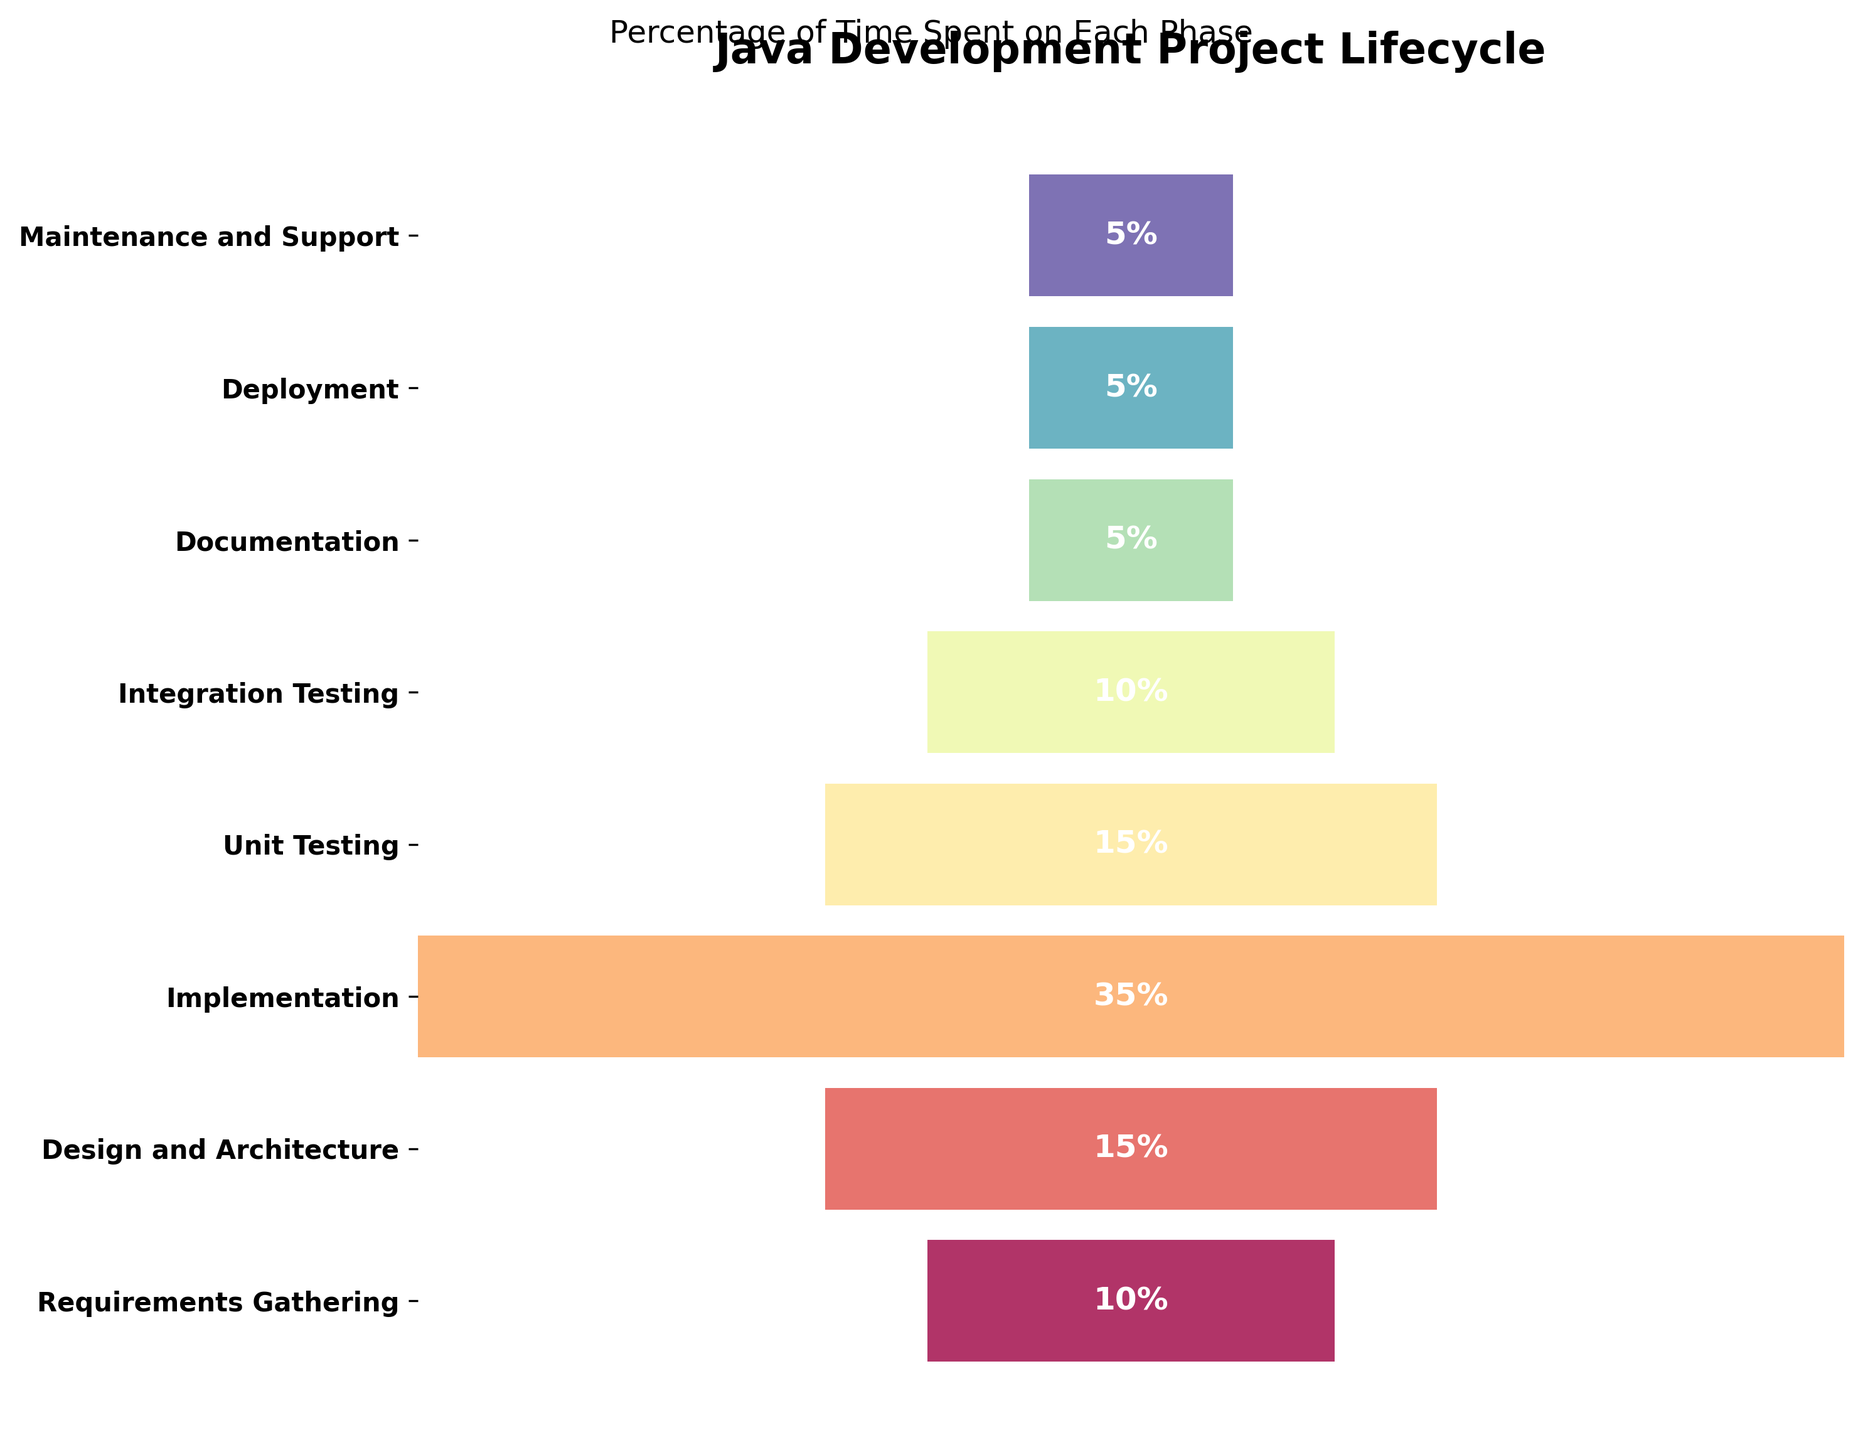What's the highest percentage of time spent on a single phase? The highest percentage can be determined by looking at the values given for each stage. The stage with the highest bar represents the highest percentage. From the figure, the 'Implementation' stage has the highest value.
Answer: 35% Which stages have an equal percentage of time spent? By comparing the percentages listed for each stage, we can see that 'Unit Testing', 'Integration Testing', 'Documentation', 'Deployment', and 'Maintenance and Support' phases all have the same value of 5%.
Answer: Documentation, Deployment, Maintenance and Support How much time in total is spent on testing phases? The testing phases here include 'Unit Testing' and 'Integration Testing'. Adding their percentages gives us 15% + 10%.
Answer: 25% Which phase has the smallest percentage of time allocated to it? The phase with the smallest percentage is determined by looking at the shortest bars in the chart. Both 'Documentation', 'Deployment', and 'Maintenance and Support' are equal and have the smallest value.
Answer: Documentation, Deployment, Maintenance and Support What is the second most time-consuming phase in the project lifecycle? To find the second most time-consuming phase, we first identify the phase with the highest percentage, which is 'Implementation', and then find the highest among the remaining phases. 'Design and Architecture' comes next with 15%.
Answer: Design and Architecture How much more time is spent on 'Implementation' compared to 'Design and Architecture'? We calculate the difference between the time spent on 'Implementation' and 'Design and Architecture'. That is 35% - 15%.
Answer: 20% What percentage of time is spent on the final three phases combined? The final three phases in the funnel chart are 'Documentation', 'Deployment', and 'Maintenance and Support'. Adding these together gives us 5% + 5% + 5%.
Answer: 15% Which phase takes up twice as much time as 'Documentation'? The 'Documentation' phase is allocated 5% of the time. The phase that takes up twice this amount would be 2*5% = 10%. By looking at the chart, 'Requirements Gathering' and 'Integration Testing' are both 10%.
Answer: Requirements Gathering, Integration Testing How many stages are there in total in the project lifecycle funnel chart? Count the number of stages listed on the vertical axis. Each stage corresponds to a data point on the funnel chart. There are 8 stages in total.
Answer: 8 What phase immediately follows 'Integration Testing' in terms of time allocation? Looking at the order of stages in the funnel chart, the phase that comes right after 'Integration Testing' is 'Documentation'.
Answer: Documentation 